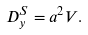<formula> <loc_0><loc_0><loc_500><loc_500>D _ { y } ^ { S } = a ^ { 2 } V .</formula> 